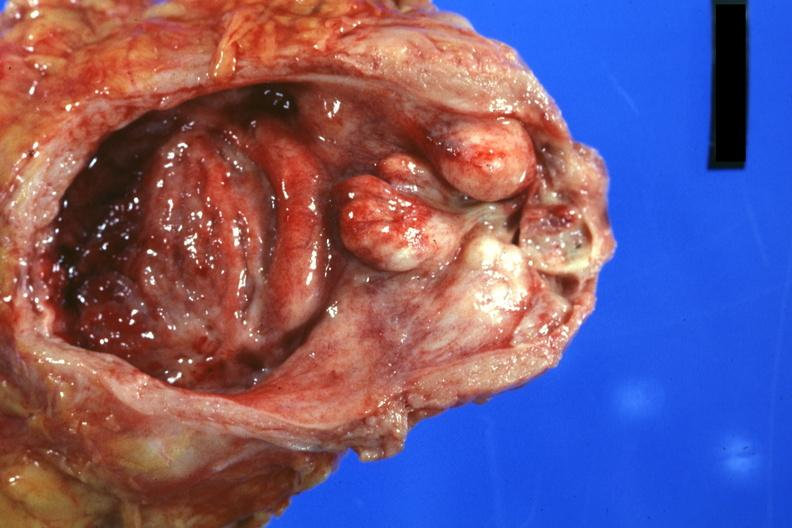does this image show good photo nodular lateral lobes large median lobe and hyperemic bladder mucosa with increased trabeculation?
Answer the question using a single word or phrase. Yes 